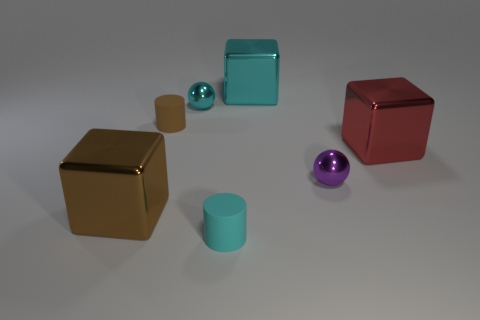Add 1 tiny cyan cylinders. How many objects exist? 8 Subtract 2 balls. How many balls are left? 0 Subtract all purple balls. How many balls are left? 1 Add 6 large yellow metal objects. How many large yellow metal objects exist? 6 Subtract 0 yellow cylinders. How many objects are left? 7 Subtract all spheres. How many objects are left? 5 Subtract all cyan cubes. Subtract all yellow cylinders. How many cubes are left? 2 Subtract all large matte objects. Subtract all brown metallic objects. How many objects are left? 6 Add 3 cyan metallic spheres. How many cyan metallic spheres are left? 4 